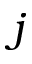<formula> <loc_0><loc_0><loc_500><loc_500>j</formula> 